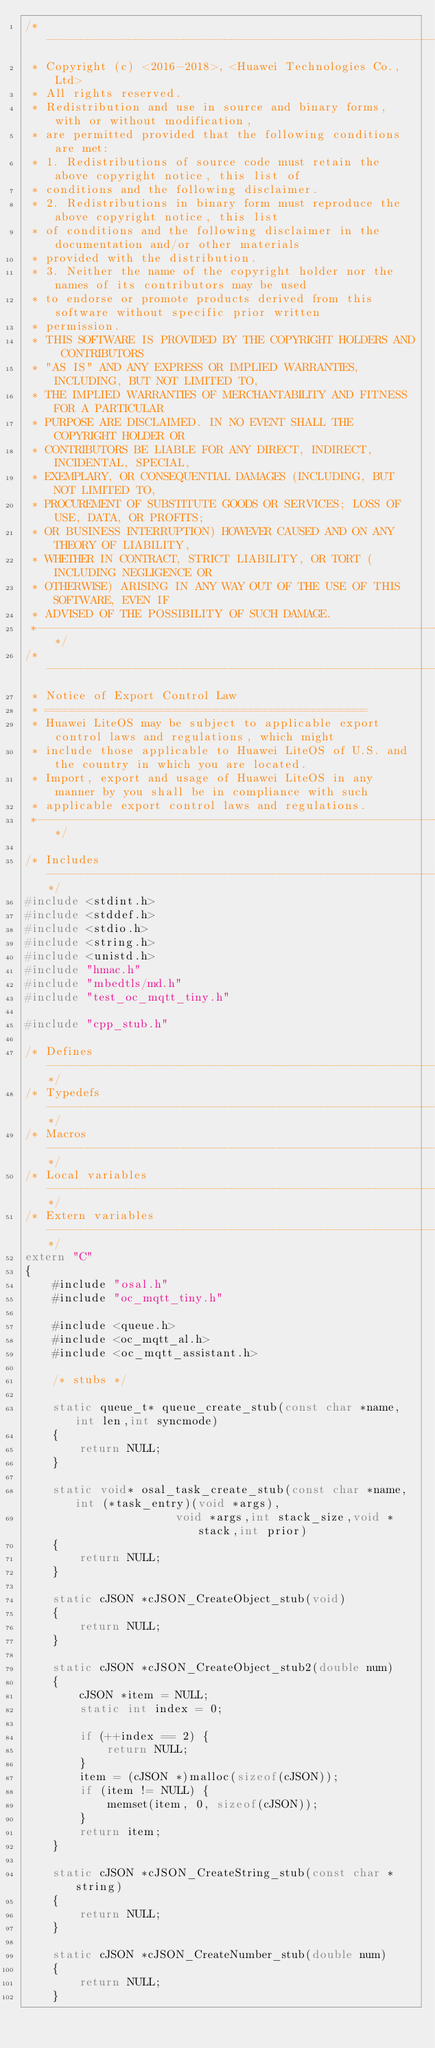Convert code to text. <code><loc_0><loc_0><loc_500><loc_500><_C++_>/*----------------------------------------------------------------------------
 * Copyright (c) <2016-2018>, <Huawei Technologies Co., Ltd>
 * All rights reserved.
 * Redistribution and use in source and binary forms, with or without modification,
 * are permitted provided that the following conditions are met:
 * 1. Redistributions of source code must retain the above copyright notice, this list of
 * conditions and the following disclaimer.
 * 2. Redistributions in binary form must reproduce the above copyright notice, this list
 * of conditions and the following disclaimer in the documentation and/or other materials
 * provided with the distribution.
 * 3. Neither the name of the copyright holder nor the names of its contributors may be used
 * to endorse or promote products derived from this software without specific prior written
 * permission.
 * THIS SOFTWARE IS PROVIDED BY THE COPYRIGHT HOLDERS AND CONTRIBUTORS
 * "AS IS" AND ANY EXPRESS OR IMPLIED WARRANTIES, INCLUDING, BUT NOT LIMITED TO,
 * THE IMPLIED WARRANTIES OF MERCHANTABILITY AND FITNESS FOR A PARTICULAR
 * PURPOSE ARE DISCLAIMED. IN NO EVENT SHALL THE COPYRIGHT HOLDER OR
 * CONTRIBUTORS BE LIABLE FOR ANY DIRECT, INDIRECT, INCIDENTAL, SPECIAL,
 * EXEMPLARY, OR CONSEQUENTIAL DAMAGES (INCLUDING, BUT NOT LIMITED TO,
 * PROCUREMENT OF SUBSTITUTE GOODS OR SERVICES; LOSS OF USE, DATA, OR PROFITS;
 * OR BUSINESS INTERRUPTION) HOWEVER CAUSED AND ON ANY THEORY OF LIABILITY,
 * WHETHER IN CONTRACT, STRICT LIABILITY, OR TORT (INCLUDING NEGLIGENCE OR
 * OTHERWISE) ARISING IN ANY WAY OUT OF THE USE OF THIS SOFTWARE, EVEN IF
 * ADVISED OF THE POSSIBILITY OF SUCH DAMAGE.
 *---------------------------------------------------------------------------*/
/*----------------------------------------------------------------------------
 * Notice of Export Control Law
 * ===============================================
 * Huawei LiteOS may be subject to applicable export control laws and regulations, which might
 * include those applicable to Huawei LiteOS of U.S. and the country in which you are located.
 * Import, export and usage of Huawei LiteOS in any manner by you shall be in compliance with such
 * applicable export control laws and regulations.
 *---------------------------------------------------------------------------*/

/* Includes -----------------------------------------------------------------*/
#include <stdint.h>
#include <stddef.h>
#include <stdio.h>
#include <string.h>
#include <unistd.h>
#include "hmac.h"
#include "mbedtls/md.h"
#include "test_oc_mqtt_tiny.h"

#include "cpp_stub.h"

/* Defines ------------------------------------------------------------------*/
/* Typedefs -----------------------------------------------------------------*/
/* Macros -------------------------------------------------------------------*/
/* Local variables ----------------------------------------------------------*/
/* Extern variables ---------------------------------------------------------*/
extern "C"
{
    #include "osal.h"
    #include "oc_mqtt_tiny.h"

    #include <queue.h>
    #include <oc_mqtt_al.h>
    #include <oc_mqtt_assistant.h>

    /* stubs */

    static queue_t* queue_create_stub(const char *name,int len,int syncmode)
    {
        return NULL;
    }

    static void* osal_task_create_stub(const char *name,int (*task_entry)(void *args),
                      void *args,int stack_size,void *stack,int prior)
    {
        return NULL;
    }

    static cJSON *cJSON_CreateObject_stub(void)
    {
        return NULL;
    }

    static cJSON *cJSON_CreateObject_stub2(double num)
    {
        cJSON *item = NULL;
        static int index = 0;

        if (++index == 2) {
            return NULL;
        }
        item = (cJSON *)malloc(sizeof(cJSON));
        if (item != NULL) {
            memset(item, 0, sizeof(cJSON));
        }
        return item;
    }

    static cJSON *cJSON_CreateString_stub(const char *string)
    {
        return NULL;
    }

    static cJSON *cJSON_CreateNumber_stub(double num)
    {
        return NULL;
    }
</code> 